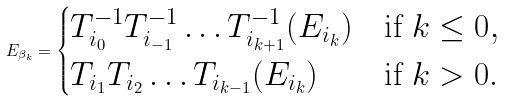Convert formula to latex. <formula><loc_0><loc_0><loc_500><loc_500>E _ { \beta _ { k } } = \begin{cases} T _ { i _ { 0 } } ^ { - 1 } T _ { i _ { - 1 } } ^ { - 1 } \dots T _ { i _ { k + 1 } } ^ { - 1 } ( E _ { i _ { k } } ) & \text {if $k\leq 0$} , \\ T _ { i _ { 1 } } T _ { i _ { 2 } } \dots T _ { i _ { k - 1 } } ( E _ { i _ { k } } ) & \text {if $k>0$} . \end{cases}</formula> 